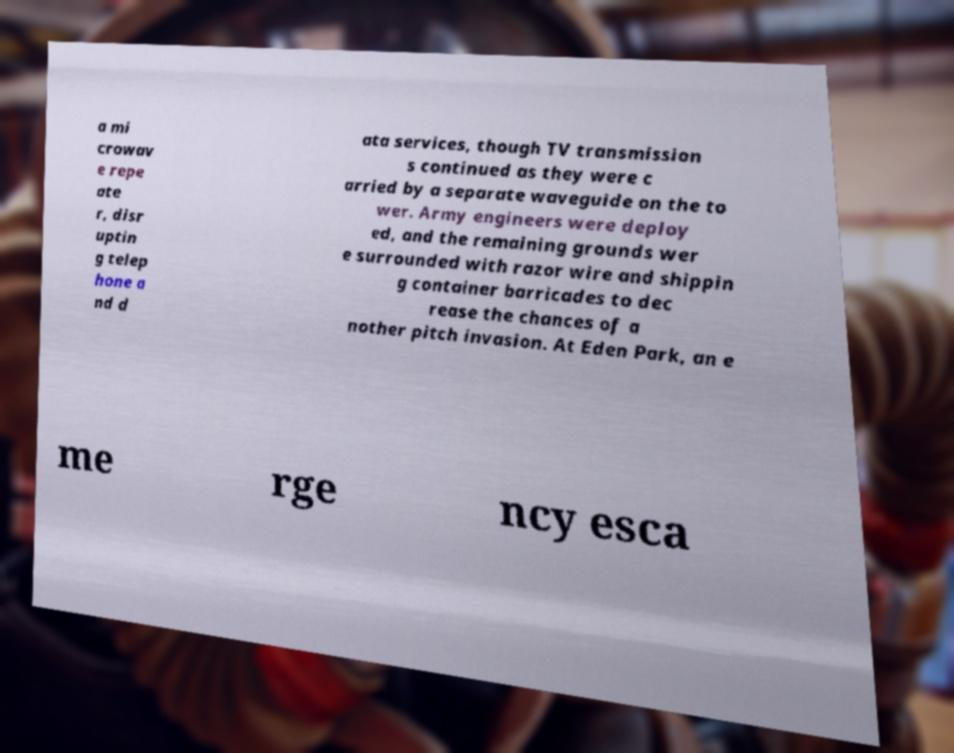What messages or text are displayed in this image? I need them in a readable, typed format. a mi crowav e repe ate r, disr uptin g telep hone a nd d ata services, though TV transmission s continued as they were c arried by a separate waveguide on the to wer. Army engineers were deploy ed, and the remaining grounds wer e surrounded with razor wire and shippin g container barricades to dec rease the chances of a nother pitch invasion. At Eden Park, an e me rge ncy esca 